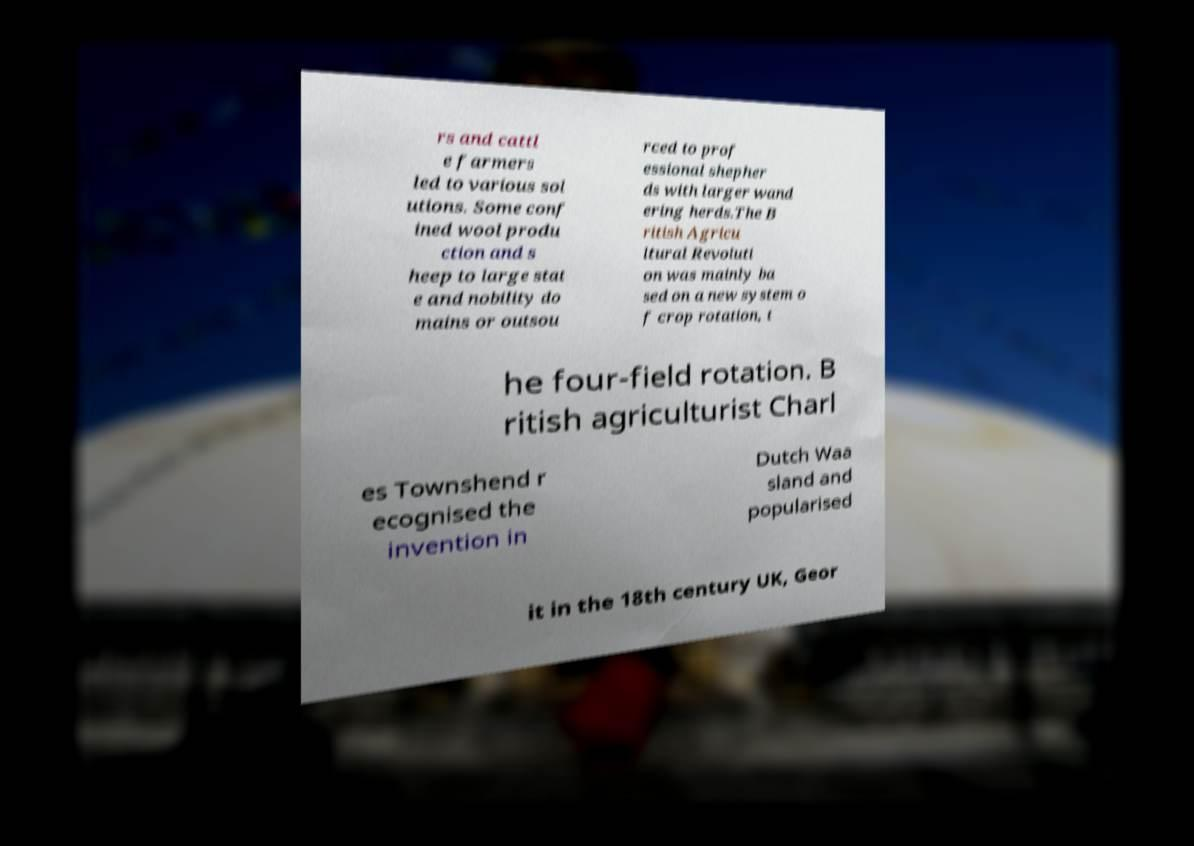Please read and relay the text visible in this image. What does it say? rs and cattl e farmers led to various sol utions. Some conf ined wool produ ction and s heep to large stat e and nobility do mains or outsou rced to prof essional shepher ds with larger wand ering herds.The B ritish Agricu ltural Revoluti on was mainly ba sed on a new system o f crop rotation, t he four-field rotation. B ritish agriculturist Charl es Townshend r ecognised the invention in Dutch Waa sland and popularised it in the 18th century UK, Geor 